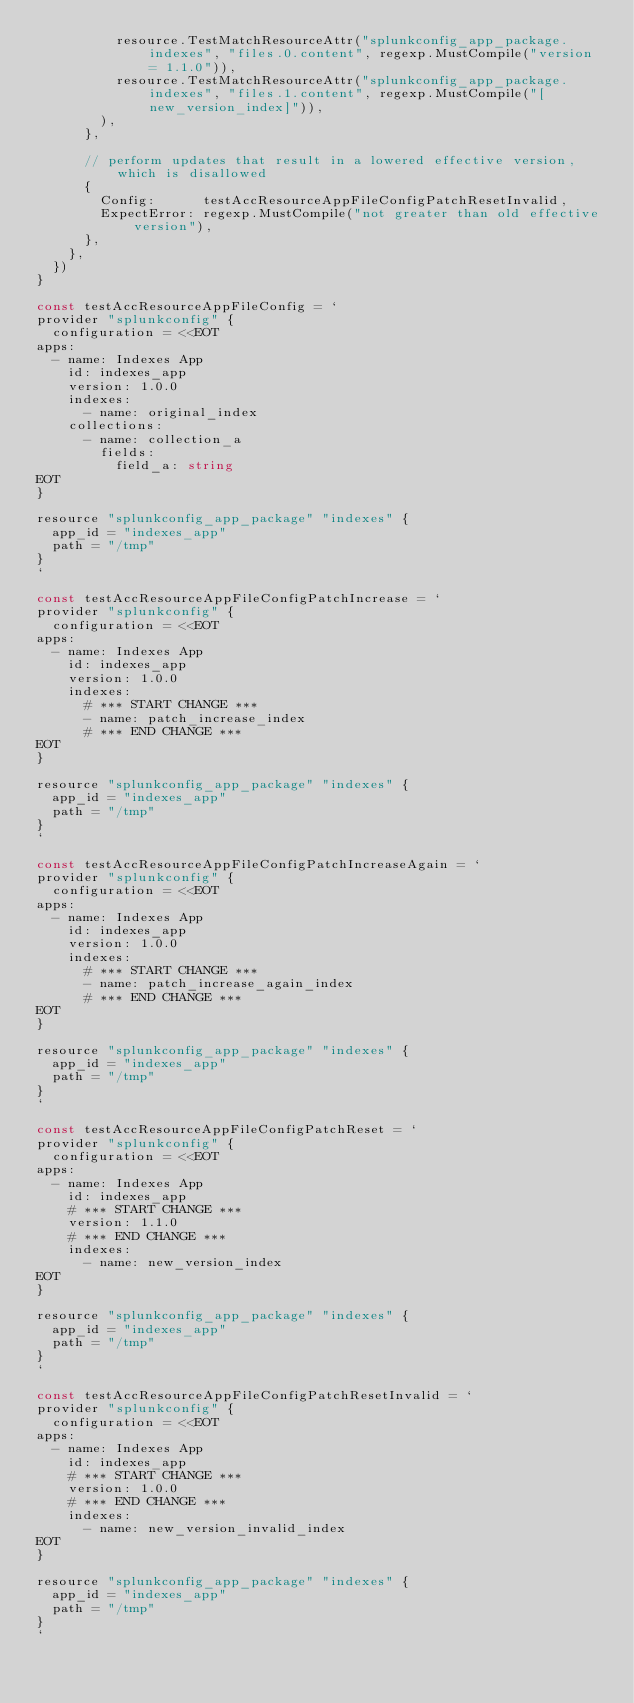<code> <loc_0><loc_0><loc_500><loc_500><_Go_>					resource.TestMatchResourceAttr("splunkconfig_app_package.indexes", "files.0.content", regexp.MustCompile("version = 1.1.0")),
					resource.TestMatchResourceAttr("splunkconfig_app_package.indexes", "files.1.content", regexp.MustCompile("[new_version_index]")),
				),
			},

			// perform updates that result in a lowered effective version, which is disallowed
			{
				Config:      testAccResourceAppFileConfigPatchResetInvalid,
				ExpectError: regexp.MustCompile("not greater than old effective version"),
			},
		},
	})
}

const testAccResourceAppFileConfig = `
provider "splunkconfig" {
	configuration = <<EOT
apps:
  - name: Indexes App
    id: indexes_app
    version: 1.0.0
    indexes:
      - name: original_index
    collections:
      - name: collection_a
        fields:
          field_a: string
EOT
}

resource "splunkconfig_app_package" "indexes" {
  app_id = "indexes_app"
  path = "/tmp"
}
`

const testAccResourceAppFileConfigPatchIncrease = `
provider "splunkconfig" {
	configuration = <<EOT
apps:
  - name: Indexes App
    id: indexes_app
    version: 1.0.0
    indexes:
      # *** START CHANGE ***
      - name: patch_increase_index
      # *** END CHANGE ***
EOT
}

resource "splunkconfig_app_package" "indexes" {
  app_id = "indexes_app"
  path = "/tmp"
}
`

const testAccResourceAppFileConfigPatchIncreaseAgain = `
provider "splunkconfig" {
	configuration = <<EOT
apps:
  - name: Indexes App
    id: indexes_app
    version: 1.0.0
    indexes:
      # *** START CHANGE ***
      - name: patch_increase_again_index
      # *** END CHANGE ***
EOT
}

resource "splunkconfig_app_package" "indexes" {
  app_id = "indexes_app"
  path = "/tmp"
}
`

const testAccResourceAppFileConfigPatchReset = `
provider "splunkconfig" {
	configuration = <<EOT
apps:
  - name: Indexes App
    id: indexes_app
    # *** START CHANGE ***
    version: 1.1.0
    # *** END CHANGE ***
    indexes:
      - name: new_version_index
EOT
}

resource "splunkconfig_app_package" "indexes" {
  app_id = "indexes_app"
  path = "/tmp"
}
`

const testAccResourceAppFileConfigPatchResetInvalid = `
provider "splunkconfig" {
	configuration = <<EOT
apps:
  - name: Indexes App
    id: indexes_app
    # *** START CHANGE ***
    version: 1.0.0
    # *** END CHANGE ***
    indexes:
      - name: new_version_invalid_index
EOT
}

resource "splunkconfig_app_package" "indexes" {
  app_id = "indexes_app"
  path = "/tmp"
}
`
</code> 